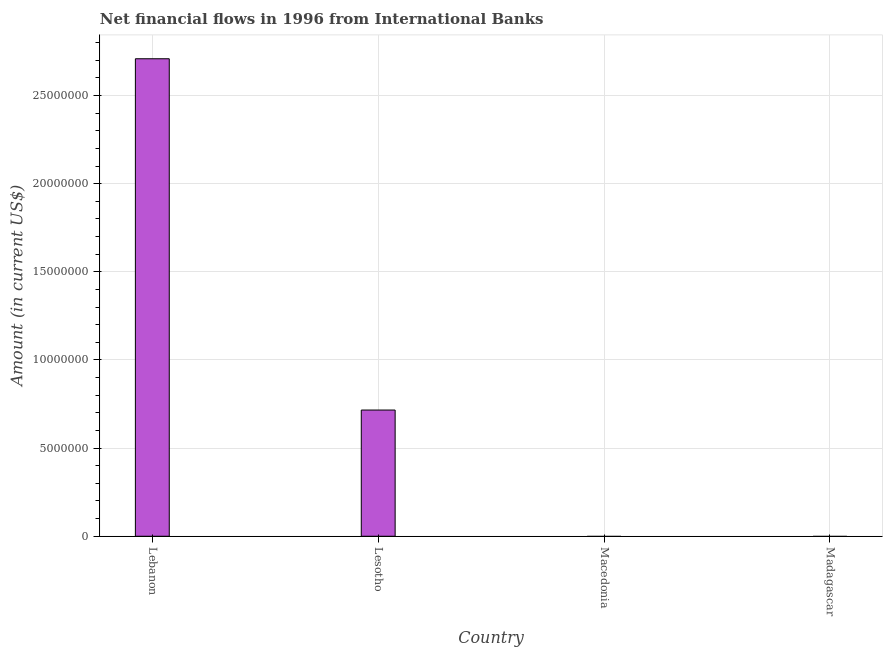Does the graph contain grids?
Keep it short and to the point. Yes. What is the title of the graph?
Your answer should be compact. Net financial flows in 1996 from International Banks. What is the label or title of the X-axis?
Keep it short and to the point. Country. What is the label or title of the Y-axis?
Provide a short and direct response. Amount (in current US$). What is the net financial flows from ibrd in Lebanon?
Your response must be concise. 2.71e+07. Across all countries, what is the maximum net financial flows from ibrd?
Ensure brevity in your answer.  2.71e+07. In which country was the net financial flows from ibrd maximum?
Ensure brevity in your answer.  Lebanon. What is the sum of the net financial flows from ibrd?
Your response must be concise. 3.42e+07. What is the difference between the net financial flows from ibrd in Lebanon and Lesotho?
Your answer should be very brief. 1.99e+07. What is the average net financial flows from ibrd per country?
Give a very brief answer. 8.56e+06. What is the median net financial flows from ibrd?
Your answer should be very brief. 3.58e+06. What is the difference between the highest and the lowest net financial flows from ibrd?
Your answer should be very brief. 2.71e+07. How many bars are there?
Your answer should be compact. 2. Are all the bars in the graph horizontal?
Your answer should be compact. No. Are the values on the major ticks of Y-axis written in scientific E-notation?
Your answer should be compact. No. What is the Amount (in current US$) in Lebanon?
Provide a short and direct response. 2.71e+07. What is the Amount (in current US$) in Lesotho?
Keep it short and to the point. 7.16e+06. What is the Amount (in current US$) of Madagascar?
Your answer should be compact. 0. What is the difference between the Amount (in current US$) in Lebanon and Lesotho?
Make the answer very short. 1.99e+07. What is the ratio of the Amount (in current US$) in Lebanon to that in Lesotho?
Ensure brevity in your answer.  3.78. 